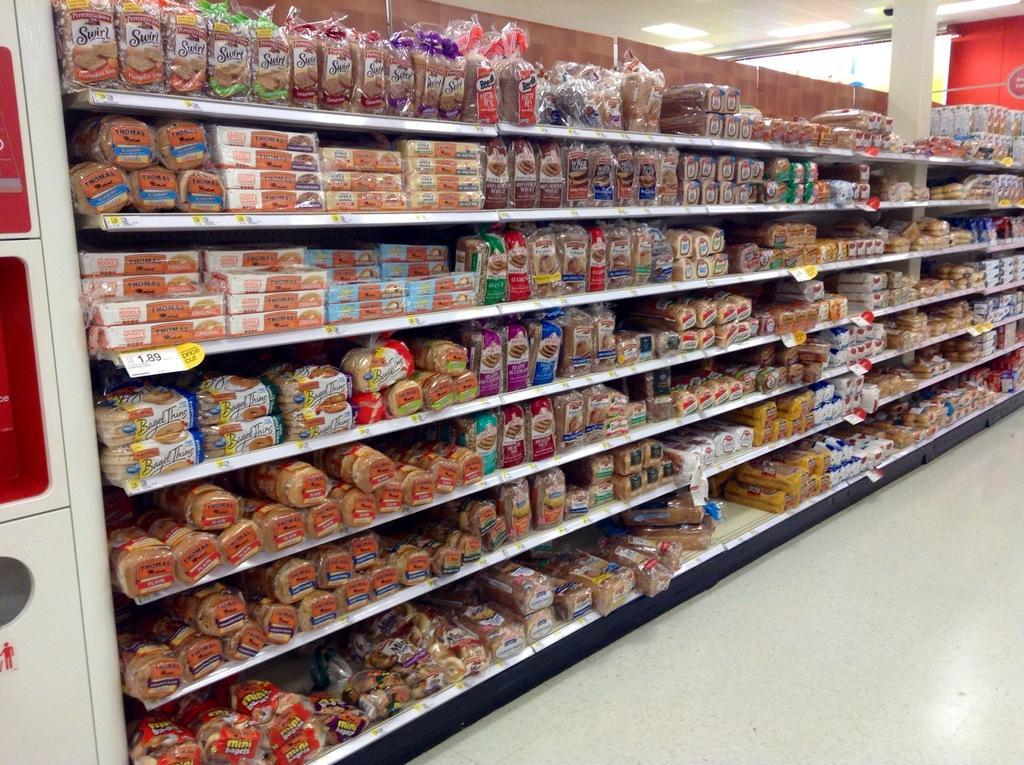How would you summarize this image in a sentence or two? In this image we can see racks with bread packets and some other items. And there is a pillar on the right side. And there is a white color object. On the ceiling there are lights. 